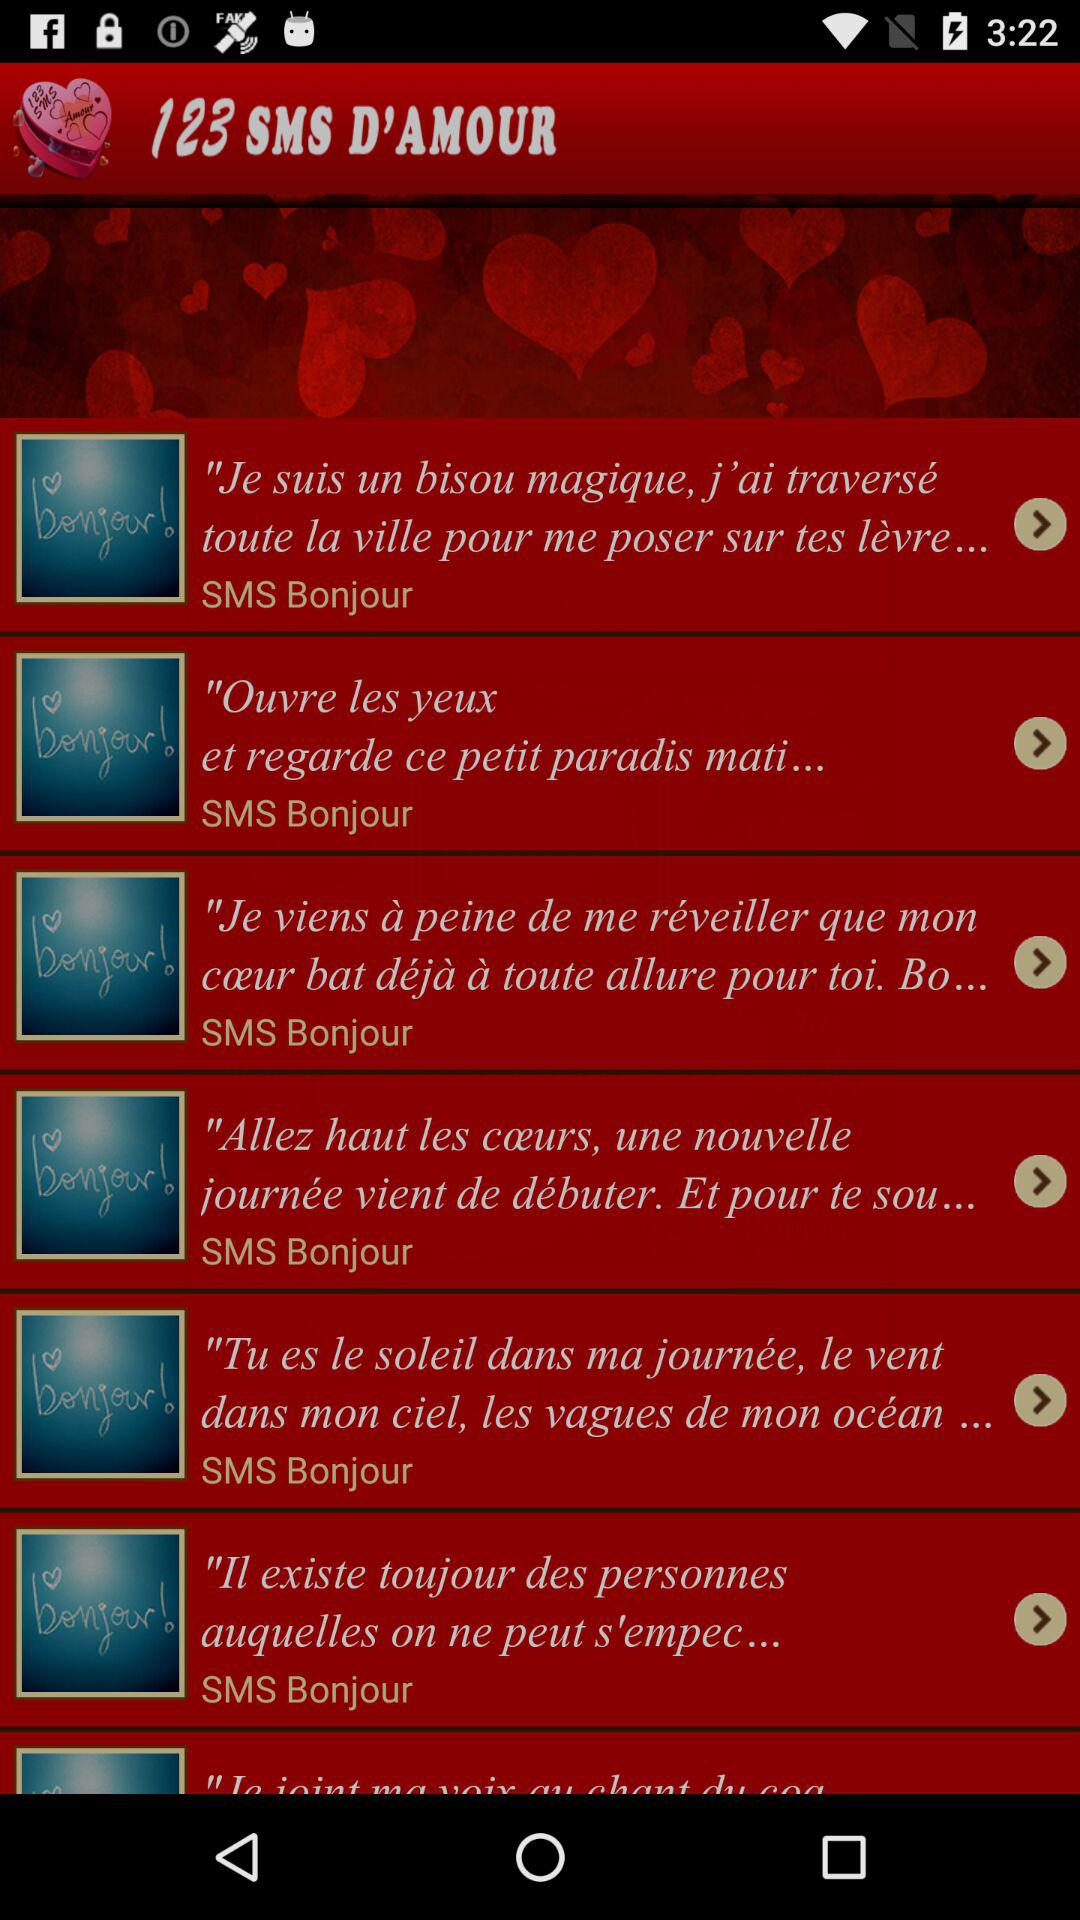What is the application name? The application name is "123 SMS D'AMOUR". 